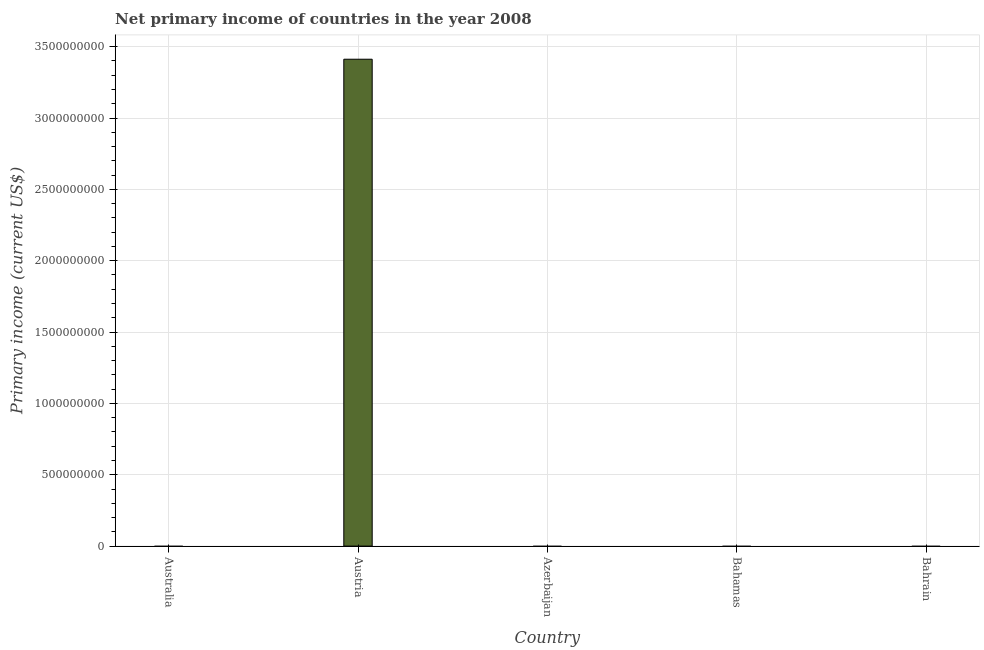Does the graph contain any zero values?
Offer a very short reply. Yes. What is the title of the graph?
Offer a very short reply. Net primary income of countries in the year 2008. What is the label or title of the Y-axis?
Provide a succinct answer. Primary income (current US$). Across all countries, what is the maximum amount of primary income?
Provide a short and direct response. 3.41e+09. In which country was the amount of primary income maximum?
Provide a succinct answer. Austria. What is the sum of the amount of primary income?
Your answer should be very brief. 3.41e+09. What is the average amount of primary income per country?
Offer a very short reply. 6.82e+08. What is the median amount of primary income?
Ensure brevity in your answer.  0. What is the difference between the highest and the lowest amount of primary income?
Provide a succinct answer. 3.41e+09. In how many countries, is the amount of primary income greater than the average amount of primary income taken over all countries?
Your response must be concise. 1. How many countries are there in the graph?
Make the answer very short. 5. What is the difference between two consecutive major ticks on the Y-axis?
Offer a terse response. 5.00e+08. Are the values on the major ticks of Y-axis written in scientific E-notation?
Offer a very short reply. No. What is the Primary income (current US$) of Austria?
Your answer should be compact. 3.41e+09. What is the Primary income (current US$) in Bahamas?
Offer a terse response. 0. What is the Primary income (current US$) of Bahrain?
Offer a very short reply. 0. 